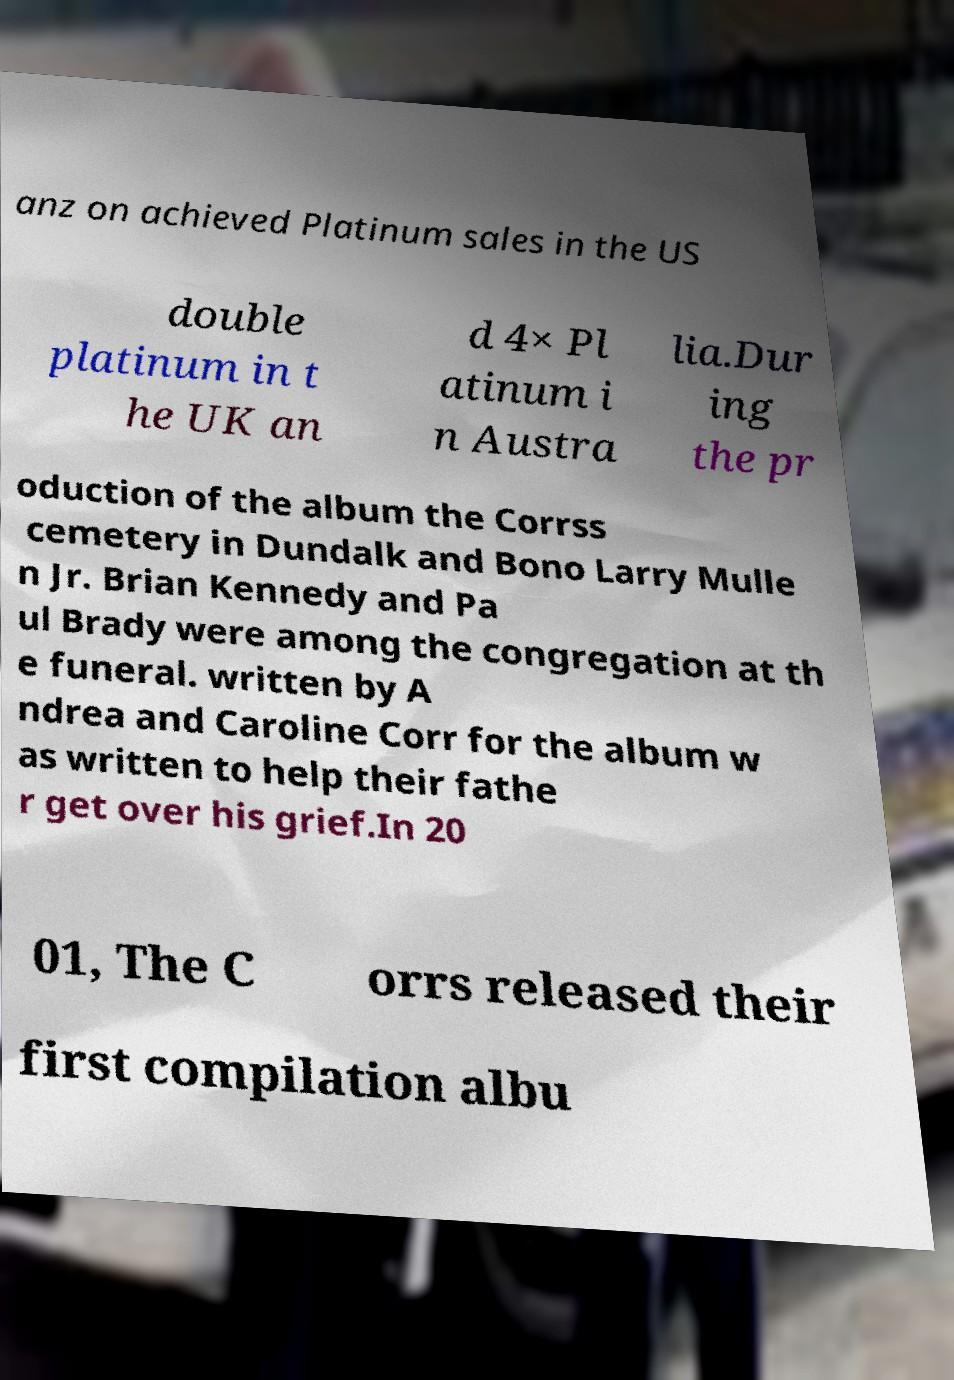Please read and relay the text visible in this image. What does it say? anz on achieved Platinum sales in the US double platinum in t he UK an d 4× Pl atinum i n Austra lia.Dur ing the pr oduction of the album the Corrss cemetery in Dundalk and Bono Larry Mulle n Jr. Brian Kennedy and Pa ul Brady were among the congregation at th e funeral. written by A ndrea and Caroline Corr for the album w as written to help their fathe r get over his grief.In 20 01, The C orrs released their first compilation albu 